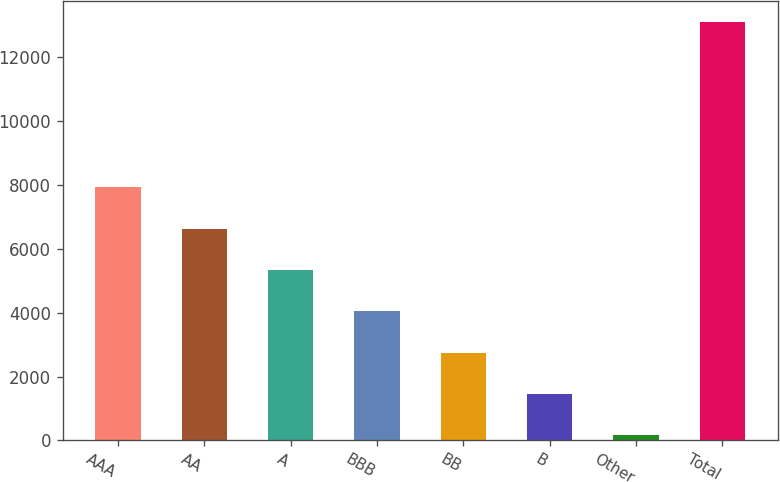Convert chart to OTSL. <chart><loc_0><loc_0><loc_500><loc_500><bar_chart><fcel>AAA<fcel>AA<fcel>A<fcel>BBB<fcel>BB<fcel>B<fcel>Other<fcel>Total<nl><fcel>7927.02<fcel>6633.5<fcel>5339.98<fcel>4046.46<fcel>2752.94<fcel>1459.42<fcel>165.9<fcel>13101.1<nl></chart> 